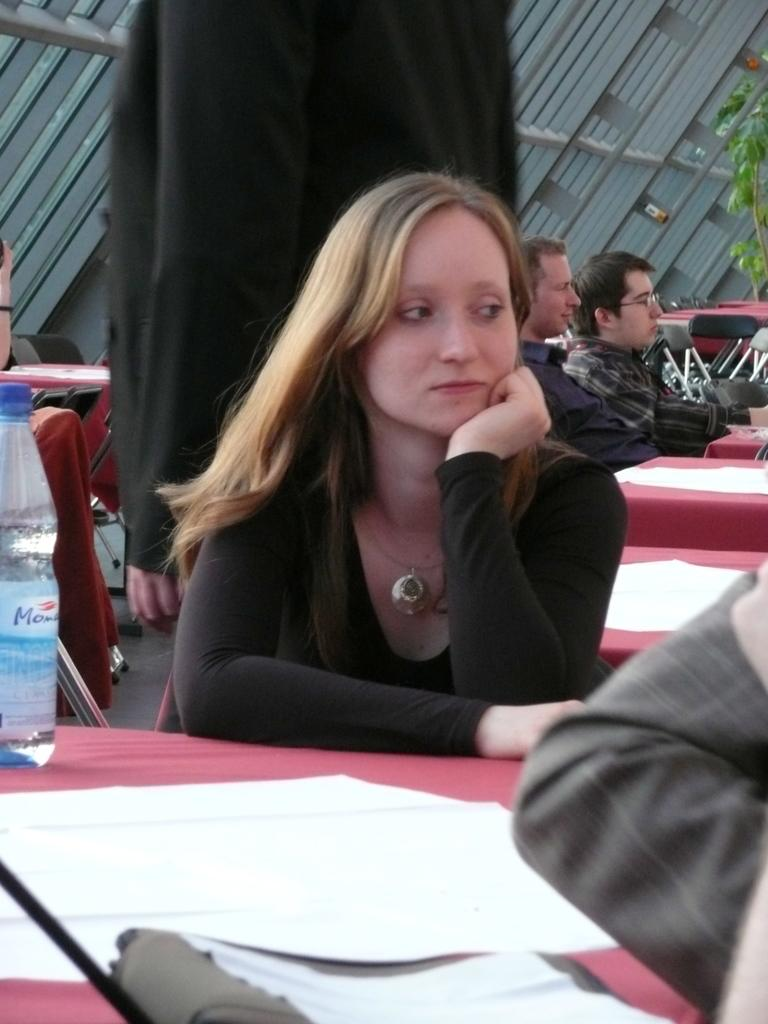What type of furniture is present in the image? There are tables and chairs in the image. What objects can be seen on the tables? Papers are present on the tables in the image. Where is the bottle located in the image? The bottle is on the left side of the image. What is on the right side of the image? There is a tree on the right side of the image. What are the people in the image doing? The people are sitting in the image. What is the color of the background in the image? The background of the image is gray. What type of alarm is ringing in the image? There is no alarm present in the image. What color is the coat worn by the person sitting in the image? There is no coat visible in the image; the people are sitting without any outerwear. 